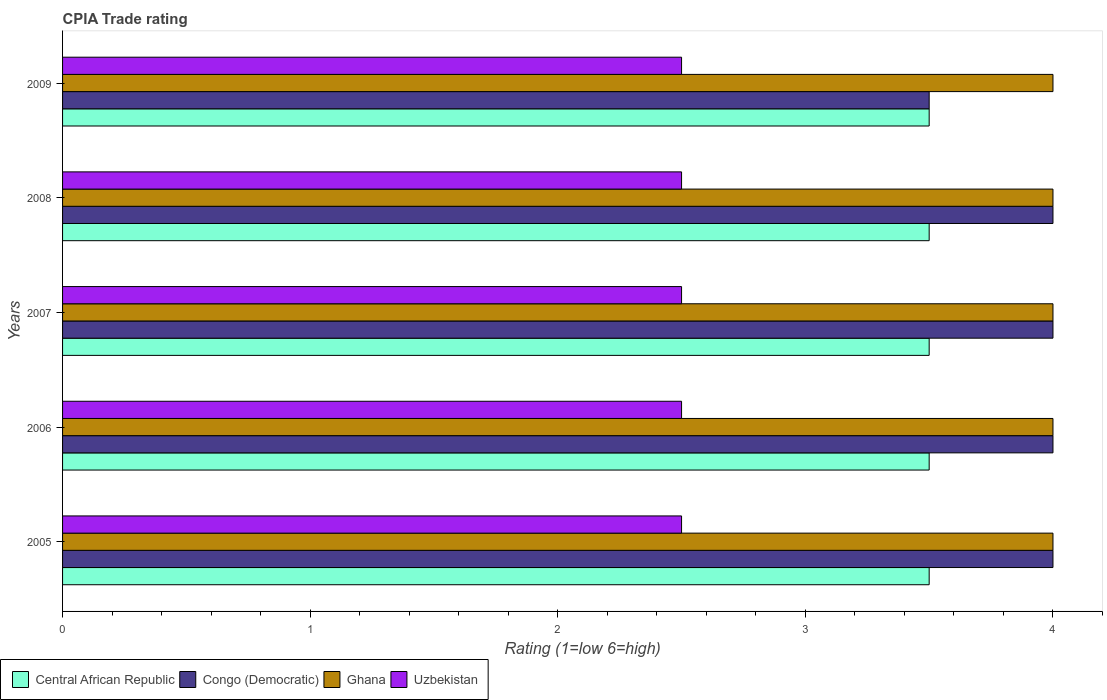Are the number of bars per tick equal to the number of legend labels?
Provide a short and direct response. Yes. What is the label of the 1st group of bars from the top?
Your answer should be very brief. 2009. In how many cases, is the number of bars for a given year not equal to the number of legend labels?
Your response must be concise. 0. What is the CPIA rating in Central African Republic in 2005?
Your answer should be very brief. 3.5. Across all years, what is the maximum CPIA rating in Ghana?
Keep it short and to the point. 4. Across all years, what is the minimum CPIA rating in Ghana?
Your response must be concise. 4. In which year was the CPIA rating in Central African Republic maximum?
Offer a very short reply. 2005. What is the total CPIA rating in Ghana in the graph?
Your response must be concise. 20. What is the difference between the CPIA rating in Central African Republic in 2007 and that in 2009?
Offer a very short reply. 0. In the year 2007, what is the difference between the CPIA rating in Ghana and CPIA rating in Central African Republic?
Offer a terse response. 0.5. In how many years, is the CPIA rating in Congo (Democratic) greater than 0.8 ?
Make the answer very short. 5. In how many years, is the CPIA rating in Uzbekistan greater than the average CPIA rating in Uzbekistan taken over all years?
Give a very brief answer. 0. Is it the case that in every year, the sum of the CPIA rating in Congo (Democratic) and CPIA rating in Uzbekistan is greater than the sum of CPIA rating in Ghana and CPIA rating in Central African Republic?
Give a very brief answer. No. What does the 1st bar from the bottom in 2006 represents?
Offer a terse response. Central African Republic. How many bars are there?
Offer a very short reply. 20. Are all the bars in the graph horizontal?
Your answer should be compact. Yes. What is the difference between two consecutive major ticks on the X-axis?
Offer a terse response. 1. Does the graph contain any zero values?
Your answer should be very brief. No. Does the graph contain grids?
Your response must be concise. No. How many legend labels are there?
Give a very brief answer. 4. How are the legend labels stacked?
Give a very brief answer. Horizontal. What is the title of the graph?
Provide a succinct answer. CPIA Trade rating. What is the label or title of the X-axis?
Give a very brief answer. Rating (1=low 6=high). What is the label or title of the Y-axis?
Your answer should be compact. Years. What is the Rating (1=low 6=high) in Central African Republic in 2005?
Keep it short and to the point. 3.5. What is the Rating (1=low 6=high) in Uzbekistan in 2005?
Offer a terse response. 2.5. What is the Rating (1=low 6=high) of Congo (Democratic) in 2006?
Your answer should be compact. 4. What is the Rating (1=low 6=high) in Ghana in 2006?
Offer a terse response. 4. What is the Rating (1=low 6=high) in Uzbekistan in 2006?
Offer a very short reply. 2.5. What is the Rating (1=low 6=high) of Central African Republic in 2007?
Your answer should be compact. 3.5. What is the Rating (1=low 6=high) in Congo (Democratic) in 2007?
Offer a very short reply. 4. What is the Rating (1=low 6=high) of Uzbekistan in 2007?
Give a very brief answer. 2.5. What is the Rating (1=low 6=high) in Ghana in 2009?
Ensure brevity in your answer.  4. Across all years, what is the maximum Rating (1=low 6=high) in Congo (Democratic)?
Your response must be concise. 4. Across all years, what is the maximum Rating (1=low 6=high) of Ghana?
Make the answer very short. 4. Across all years, what is the minimum Rating (1=low 6=high) of Uzbekistan?
Provide a short and direct response. 2.5. What is the total Rating (1=low 6=high) of Central African Republic in the graph?
Give a very brief answer. 17.5. What is the total Rating (1=low 6=high) in Congo (Democratic) in the graph?
Offer a terse response. 19.5. What is the total Rating (1=low 6=high) in Ghana in the graph?
Your answer should be very brief. 20. What is the total Rating (1=low 6=high) in Uzbekistan in the graph?
Give a very brief answer. 12.5. What is the difference between the Rating (1=low 6=high) in Central African Republic in 2005 and that in 2006?
Make the answer very short. 0. What is the difference between the Rating (1=low 6=high) in Congo (Democratic) in 2005 and that in 2006?
Keep it short and to the point. 0. What is the difference between the Rating (1=low 6=high) in Uzbekistan in 2005 and that in 2006?
Give a very brief answer. 0. What is the difference between the Rating (1=low 6=high) in Central African Republic in 2005 and that in 2007?
Make the answer very short. 0. What is the difference between the Rating (1=low 6=high) of Ghana in 2005 and that in 2007?
Your answer should be compact. 0. What is the difference between the Rating (1=low 6=high) of Central African Republic in 2005 and that in 2008?
Keep it short and to the point. 0. What is the difference between the Rating (1=low 6=high) of Ghana in 2005 and that in 2008?
Offer a terse response. 0. What is the difference between the Rating (1=low 6=high) of Ghana in 2005 and that in 2009?
Offer a very short reply. 0. What is the difference between the Rating (1=low 6=high) of Ghana in 2006 and that in 2007?
Offer a very short reply. 0. What is the difference between the Rating (1=low 6=high) in Uzbekistan in 2006 and that in 2007?
Your answer should be compact. 0. What is the difference between the Rating (1=low 6=high) of Central African Republic in 2006 and that in 2008?
Make the answer very short. 0. What is the difference between the Rating (1=low 6=high) of Ghana in 2006 and that in 2008?
Provide a succinct answer. 0. What is the difference between the Rating (1=low 6=high) of Central African Republic in 2006 and that in 2009?
Your answer should be very brief. 0. What is the difference between the Rating (1=low 6=high) of Congo (Democratic) in 2006 and that in 2009?
Provide a succinct answer. 0.5. What is the difference between the Rating (1=low 6=high) of Ghana in 2006 and that in 2009?
Make the answer very short. 0. What is the difference between the Rating (1=low 6=high) of Uzbekistan in 2006 and that in 2009?
Your response must be concise. 0. What is the difference between the Rating (1=low 6=high) in Central African Republic in 2007 and that in 2008?
Provide a succinct answer. 0. What is the difference between the Rating (1=low 6=high) of Congo (Democratic) in 2007 and that in 2009?
Your answer should be compact. 0.5. What is the difference between the Rating (1=low 6=high) of Ghana in 2007 and that in 2009?
Provide a succinct answer. 0. What is the difference between the Rating (1=low 6=high) in Uzbekistan in 2007 and that in 2009?
Ensure brevity in your answer.  0. What is the difference between the Rating (1=low 6=high) in Congo (Democratic) in 2008 and that in 2009?
Provide a short and direct response. 0.5. What is the difference between the Rating (1=low 6=high) in Central African Republic in 2005 and the Rating (1=low 6=high) in Ghana in 2006?
Your answer should be very brief. -0.5. What is the difference between the Rating (1=low 6=high) in Central African Republic in 2005 and the Rating (1=low 6=high) in Uzbekistan in 2006?
Provide a succinct answer. 1. What is the difference between the Rating (1=low 6=high) in Congo (Democratic) in 2005 and the Rating (1=low 6=high) in Ghana in 2006?
Ensure brevity in your answer.  0. What is the difference between the Rating (1=low 6=high) in Congo (Democratic) in 2005 and the Rating (1=low 6=high) in Uzbekistan in 2006?
Provide a short and direct response. 1.5. What is the difference between the Rating (1=low 6=high) in Ghana in 2005 and the Rating (1=low 6=high) in Uzbekistan in 2006?
Offer a terse response. 1.5. What is the difference between the Rating (1=low 6=high) of Central African Republic in 2005 and the Rating (1=low 6=high) of Uzbekistan in 2007?
Your response must be concise. 1. What is the difference between the Rating (1=low 6=high) in Congo (Democratic) in 2005 and the Rating (1=low 6=high) in Ghana in 2007?
Provide a succinct answer. 0. What is the difference between the Rating (1=low 6=high) in Central African Republic in 2005 and the Rating (1=low 6=high) in Uzbekistan in 2008?
Provide a succinct answer. 1. What is the difference between the Rating (1=low 6=high) of Ghana in 2005 and the Rating (1=low 6=high) of Uzbekistan in 2008?
Keep it short and to the point. 1.5. What is the difference between the Rating (1=low 6=high) in Central African Republic in 2005 and the Rating (1=low 6=high) in Ghana in 2009?
Provide a succinct answer. -0.5. What is the difference between the Rating (1=low 6=high) of Central African Republic in 2005 and the Rating (1=low 6=high) of Uzbekistan in 2009?
Give a very brief answer. 1. What is the difference between the Rating (1=low 6=high) in Congo (Democratic) in 2005 and the Rating (1=low 6=high) in Uzbekistan in 2009?
Keep it short and to the point. 1.5. What is the difference between the Rating (1=low 6=high) in Ghana in 2005 and the Rating (1=low 6=high) in Uzbekistan in 2009?
Give a very brief answer. 1.5. What is the difference between the Rating (1=low 6=high) of Central African Republic in 2006 and the Rating (1=low 6=high) of Congo (Democratic) in 2007?
Provide a short and direct response. -0.5. What is the difference between the Rating (1=low 6=high) of Ghana in 2006 and the Rating (1=low 6=high) of Uzbekistan in 2007?
Your response must be concise. 1.5. What is the difference between the Rating (1=low 6=high) of Central African Republic in 2006 and the Rating (1=low 6=high) of Congo (Democratic) in 2008?
Keep it short and to the point. -0.5. What is the difference between the Rating (1=low 6=high) in Ghana in 2006 and the Rating (1=low 6=high) in Uzbekistan in 2008?
Your answer should be very brief. 1.5. What is the difference between the Rating (1=low 6=high) in Central African Republic in 2006 and the Rating (1=low 6=high) in Congo (Democratic) in 2009?
Provide a short and direct response. 0. What is the difference between the Rating (1=low 6=high) in Central African Republic in 2006 and the Rating (1=low 6=high) in Ghana in 2009?
Your response must be concise. -0.5. What is the difference between the Rating (1=low 6=high) of Congo (Democratic) in 2007 and the Rating (1=low 6=high) of Ghana in 2008?
Make the answer very short. 0. What is the difference between the Rating (1=low 6=high) of Congo (Democratic) in 2007 and the Rating (1=low 6=high) of Uzbekistan in 2008?
Offer a terse response. 1.5. What is the difference between the Rating (1=low 6=high) of Central African Republic in 2007 and the Rating (1=low 6=high) of Uzbekistan in 2009?
Your response must be concise. 1. What is the difference between the Rating (1=low 6=high) in Central African Republic in 2008 and the Rating (1=low 6=high) in Congo (Democratic) in 2009?
Give a very brief answer. 0. What is the difference between the Rating (1=low 6=high) in Central African Republic in 2008 and the Rating (1=low 6=high) in Ghana in 2009?
Ensure brevity in your answer.  -0.5. What is the difference between the Rating (1=low 6=high) in Central African Republic in 2008 and the Rating (1=low 6=high) in Uzbekistan in 2009?
Offer a very short reply. 1. What is the difference between the Rating (1=low 6=high) of Congo (Democratic) in 2008 and the Rating (1=low 6=high) of Ghana in 2009?
Make the answer very short. 0. What is the difference between the Rating (1=low 6=high) of Ghana in 2008 and the Rating (1=low 6=high) of Uzbekistan in 2009?
Your answer should be very brief. 1.5. What is the average Rating (1=low 6=high) in Congo (Democratic) per year?
Your response must be concise. 3.9. What is the average Rating (1=low 6=high) of Ghana per year?
Offer a terse response. 4. What is the average Rating (1=low 6=high) in Uzbekistan per year?
Offer a terse response. 2.5. In the year 2005, what is the difference between the Rating (1=low 6=high) in Central African Republic and Rating (1=low 6=high) in Congo (Democratic)?
Ensure brevity in your answer.  -0.5. In the year 2005, what is the difference between the Rating (1=low 6=high) in Central African Republic and Rating (1=low 6=high) in Uzbekistan?
Ensure brevity in your answer.  1. In the year 2005, what is the difference between the Rating (1=low 6=high) in Congo (Democratic) and Rating (1=low 6=high) in Ghana?
Make the answer very short. 0. In the year 2005, what is the difference between the Rating (1=low 6=high) in Ghana and Rating (1=low 6=high) in Uzbekistan?
Your response must be concise. 1.5. In the year 2006, what is the difference between the Rating (1=low 6=high) of Central African Republic and Rating (1=low 6=high) of Congo (Democratic)?
Provide a succinct answer. -0.5. In the year 2006, what is the difference between the Rating (1=low 6=high) in Central African Republic and Rating (1=low 6=high) in Ghana?
Your answer should be very brief. -0.5. In the year 2006, what is the difference between the Rating (1=low 6=high) in Central African Republic and Rating (1=low 6=high) in Uzbekistan?
Provide a short and direct response. 1. In the year 2006, what is the difference between the Rating (1=low 6=high) of Congo (Democratic) and Rating (1=low 6=high) of Uzbekistan?
Offer a terse response. 1.5. In the year 2007, what is the difference between the Rating (1=low 6=high) in Central African Republic and Rating (1=low 6=high) in Congo (Democratic)?
Give a very brief answer. -0.5. In the year 2007, what is the difference between the Rating (1=low 6=high) of Central African Republic and Rating (1=low 6=high) of Ghana?
Provide a short and direct response. -0.5. In the year 2007, what is the difference between the Rating (1=low 6=high) in Congo (Democratic) and Rating (1=low 6=high) in Ghana?
Make the answer very short. 0. In the year 2008, what is the difference between the Rating (1=low 6=high) of Central African Republic and Rating (1=low 6=high) of Congo (Democratic)?
Provide a succinct answer. -0.5. In the year 2008, what is the difference between the Rating (1=low 6=high) of Central African Republic and Rating (1=low 6=high) of Ghana?
Offer a very short reply. -0.5. In the year 2008, what is the difference between the Rating (1=low 6=high) of Central African Republic and Rating (1=low 6=high) of Uzbekistan?
Offer a terse response. 1. In the year 2008, what is the difference between the Rating (1=low 6=high) of Congo (Democratic) and Rating (1=low 6=high) of Ghana?
Keep it short and to the point. 0. In the year 2008, what is the difference between the Rating (1=low 6=high) of Congo (Democratic) and Rating (1=low 6=high) of Uzbekistan?
Provide a short and direct response. 1.5. In the year 2008, what is the difference between the Rating (1=low 6=high) in Ghana and Rating (1=low 6=high) in Uzbekistan?
Provide a succinct answer. 1.5. In the year 2009, what is the difference between the Rating (1=low 6=high) in Central African Republic and Rating (1=low 6=high) in Congo (Democratic)?
Offer a terse response. 0. In the year 2009, what is the difference between the Rating (1=low 6=high) of Congo (Democratic) and Rating (1=low 6=high) of Ghana?
Provide a short and direct response. -0.5. What is the ratio of the Rating (1=low 6=high) in Ghana in 2005 to that in 2006?
Provide a short and direct response. 1. What is the ratio of the Rating (1=low 6=high) in Central African Republic in 2005 to that in 2007?
Keep it short and to the point. 1. What is the ratio of the Rating (1=low 6=high) in Ghana in 2005 to that in 2007?
Give a very brief answer. 1. What is the ratio of the Rating (1=low 6=high) in Uzbekistan in 2005 to that in 2007?
Give a very brief answer. 1. What is the ratio of the Rating (1=low 6=high) of Congo (Democratic) in 2005 to that in 2008?
Offer a terse response. 1. What is the ratio of the Rating (1=low 6=high) of Ghana in 2005 to that in 2008?
Your answer should be very brief. 1. What is the ratio of the Rating (1=low 6=high) of Congo (Democratic) in 2005 to that in 2009?
Your response must be concise. 1.14. What is the ratio of the Rating (1=low 6=high) in Ghana in 2005 to that in 2009?
Your answer should be very brief. 1. What is the ratio of the Rating (1=low 6=high) of Uzbekistan in 2005 to that in 2009?
Your answer should be very brief. 1. What is the ratio of the Rating (1=low 6=high) of Congo (Democratic) in 2006 to that in 2007?
Make the answer very short. 1. What is the ratio of the Rating (1=low 6=high) of Uzbekistan in 2006 to that in 2007?
Give a very brief answer. 1. What is the ratio of the Rating (1=low 6=high) in Central African Republic in 2006 to that in 2008?
Provide a short and direct response. 1. What is the ratio of the Rating (1=low 6=high) of Ghana in 2006 to that in 2008?
Ensure brevity in your answer.  1. What is the ratio of the Rating (1=low 6=high) in Ghana in 2006 to that in 2009?
Ensure brevity in your answer.  1. What is the ratio of the Rating (1=low 6=high) in Uzbekistan in 2006 to that in 2009?
Your answer should be compact. 1. What is the ratio of the Rating (1=low 6=high) of Uzbekistan in 2007 to that in 2008?
Your answer should be compact. 1. What is the ratio of the Rating (1=low 6=high) of Central African Republic in 2007 to that in 2009?
Provide a short and direct response. 1. What is the ratio of the Rating (1=low 6=high) of Ghana in 2007 to that in 2009?
Make the answer very short. 1. What is the ratio of the Rating (1=low 6=high) in Uzbekistan in 2007 to that in 2009?
Ensure brevity in your answer.  1. What is the ratio of the Rating (1=low 6=high) of Central African Republic in 2008 to that in 2009?
Ensure brevity in your answer.  1. What is the ratio of the Rating (1=low 6=high) of Uzbekistan in 2008 to that in 2009?
Provide a succinct answer. 1. What is the difference between the highest and the second highest Rating (1=low 6=high) of Central African Republic?
Offer a very short reply. 0. What is the difference between the highest and the second highest Rating (1=low 6=high) in Congo (Democratic)?
Ensure brevity in your answer.  0. What is the difference between the highest and the second highest Rating (1=low 6=high) in Ghana?
Keep it short and to the point. 0. What is the difference between the highest and the second highest Rating (1=low 6=high) of Uzbekistan?
Give a very brief answer. 0. What is the difference between the highest and the lowest Rating (1=low 6=high) in Ghana?
Offer a very short reply. 0. What is the difference between the highest and the lowest Rating (1=low 6=high) of Uzbekistan?
Make the answer very short. 0. 